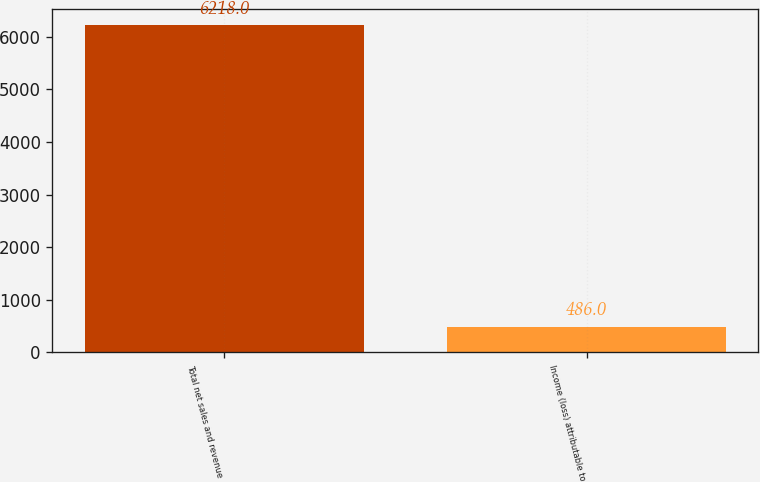Convert chart. <chart><loc_0><loc_0><loc_500><loc_500><bar_chart><fcel>Total net sales and revenue<fcel>Income (loss) attributable to<nl><fcel>6218<fcel>486<nl></chart> 